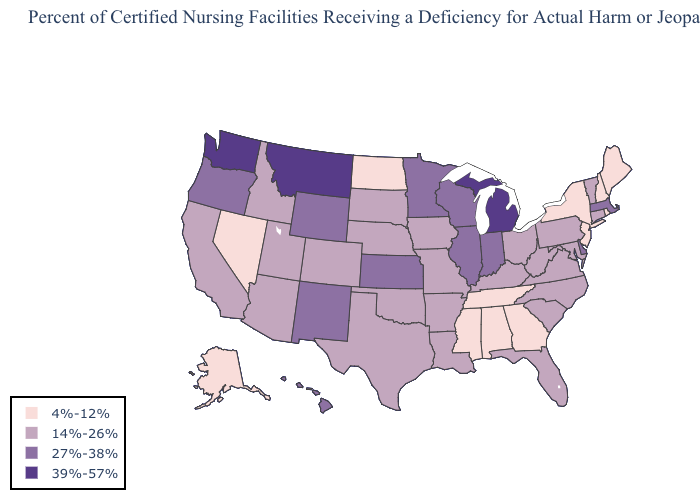Which states have the highest value in the USA?
Write a very short answer. Michigan, Montana, Washington. What is the highest value in states that border Maryland?
Answer briefly. 27%-38%. Name the states that have a value in the range 14%-26%?
Short answer required. Arizona, Arkansas, California, Colorado, Connecticut, Florida, Idaho, Iowa, Kentucky, Louisiana, Maryland, Missouri, Nebraska, North Carolina, Ohio, Oklahoma, Pennsylvania, South Carolina, South Dakota, Texas, Utah, Vermont, Virginia, West Virginia. What is the lowest value in the USA?
Answer briefly. 4%-12%. Which states have the highest value in the USA?
Write a very short answer. Michigan, Montana, Washington. Name the states that have a value in the range 27%-38%?
Give a very brief answer. Delaware, Hawaii, Illinois, Indiana, Kansas, Massachusetts, Minnesota, New Mexico, Oregon, Wisconsin, Wyoming. Which states have the lowest value in the USA?
Short answer required. Alabama, Alaska, Georgia, Maine, Mississippi, Nevada, New Hampshire, New Jersey, New York, North Dakota, Rhode Island, Tennessee. What is the highest value in states that border Kansas?
Give a very brief answer. 14%-26%. What is the highest value in the West ?
Concise answer only. 39%-57%. Does Washington have a higher value than Montana?
Quick response, please. No. What is the highest value in the USA?
Short answer required. 39%-57%. Does the first symbol in the legend represent the smallest category?
Be succinct. Yes. Does Minnesota have the lowest value in the MidWest?
Answer briefly. No. Among the states that border Washington , which have the lowest value?
Quick response, please. Idaho. Which states have the lowest value in the USA?
Give a very brief answer. Alabama, Alaska, Georgia, Maine, Mississippi, Nevada, New Hampshire, New Jersey, New York, North Dakota, Rhode Island, Tennessee. 